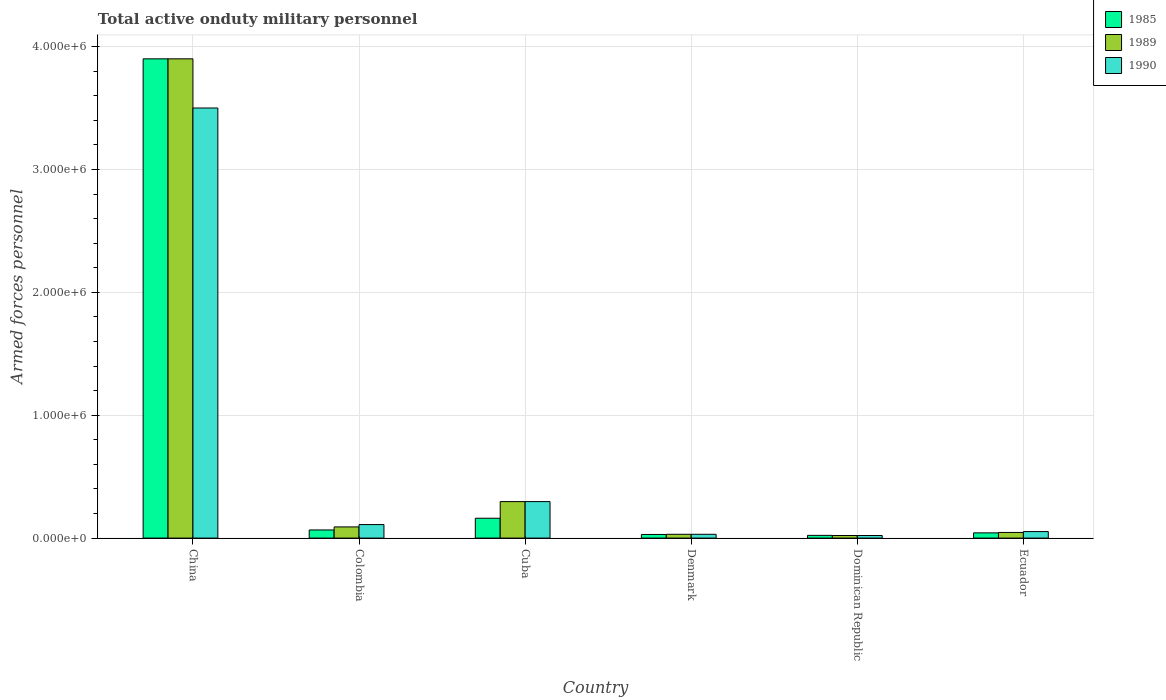How many different coloured bars are there?
Give a very brief answer. 3. How many bars are there on the 5th tick from the left?
Give a very brief answer. 3. How many bars are there on the 2nd tick from the right?
Make the answer very short. 3. What is the label of the 6th group of bars from the left?
Provide a short and direct response. Ecuador. In how many cases, is the number of bars for a given country not equal to the number of legend labels?
Your answer should be compact. 0. What is the number of armed forces personnel in 1985 in China?
Your answer should be very brief. 3.90e+06. Across all countries, what is the maximum number of armed forces personnel in 1985?
Your answer should be compact. 3.90e+06. Across all countries, what is the minimum number of armed forces personnel in 1989?
Your answer should be very brief. 2.10e+04. In which country was the number of armed forces personnel in 1989 minimum?
Make the answer very short. Dominican Republic. What is the total number of armed forces personnel in 1990 in the graph?
Offer a terse response. 4.01e+06. What is the difference between the number of armed forces personnel in 1990 in China and that in Dominican Republic?
Your response must be concise. 3.48e+06. What is the difference between the number of armed forces personnel in 1990 in Colombia and the number of armed forces personnel in 1989 in Ecuador?
Make the answer very short. 6.40e+04. What is the average number of armed forces personnel in 1990 per country?
Keep it short and to the point. 6.69e+05. In how many countries, is the number of armed forces personnel in 1990 greater than 200000?
Provide a succinct answer. 2. What is the ratio of the number of armed forces personnel in 1990 in Colombia to that in Dominican Republic?
Your answer should be very brief. 5.24. Is the number of armed forces personnel in 1989 in Colombia less than that in Cuba?
Offer a very short reply. Yes. What is the difference between the highest and the second highest number of armed forces personnel in 1985?
Ensure brevity in your answer.  3.74e+06. What is the difference between the highest and the lowest number of armed forces personnel in 1985?
Provide a short and direct response. 3.88e+06. In how many countries, is the number of armed forces personnel in 1989 greater than the average number of armed forces personnel in 1989 taken over all countries?
Provide a succinct answer. 1. Is the sum of the number of armed forces personnel in 1990 in Denmark and Ecuador greater than the maximum number of armed forces personnel in 1989 across all countries?
Make the answer very short. No. What does the 1st bar from the left in Ecuador represents?
Give a very brief answer. 1985. What does the 1st bar from the right in Dominican Republic represents?
Offer a very short reply. 1990. Are all the bars in the graph horizontal?
Your response must be concise. No. Does the graph contain any zero values?
Provide a short and direct response. No. What is the title of the graph?
Ensure brevity in your answer.  Total active onduty military personnel. Does "2013" appear as one of the legend labels in the graph?
Your answer should be compact. No. What is the label or title of the X-axis?
Your answer should be compact. Country. What is the label or title of the Y-axis?
Your answer should be compact. Armed forces personnel. What is the Armed forces personnel in 1985 in China?
Provide a short and direct response. 3.90e+06. What is the Armed forces personnel of 1989 in China?
Your response must be concise. 3.90e+06. What is the Armed forces personnel in 1990 in China?
Ensure brevity in your answer.  3.50e+06. What is the Armed forces personnel in 1985 in Colombia?
Give a very brief answer. 6.62e+04. What is the Armed forces personnel of 1989 in Colombia?
Make the answer very short. 9.10e+04. What is the Armed forces personnel of 1990 in Colombia?
Provide a succinct answer. 1.10e+05. What is the Armed forces personnel of 1985 in Cuba?
Your answer should be very brief. 1.62e+05. What is the Armed forces personnel in 1989 in Cuba?
Keep it short and to the point. 2.97e+05. What is the Armed forces personnel in 1990 in Cuba?
Give a very brief answer. 2.97e+05. What is the Armed forces personnel in 1985 in Denmark?
Your answer should be compact. 2.96e+04. What is the Armed forces personnel of 1989 in Denmark?
Your answer should be compact. 3.10e+04. What is the Armed forces personnel in 1990 in Denmark?
Keep it short and to the point. 3.10e+04. What is the Armed forces personnel in 1985 in Dominican Republic?
Provide a succinct answer. 2.22e+04. What is the Armed forces personnel of 1989 in Dominican Republic?
Your response must be concise. 2.10e+04. What is the Armed forces personnel in 1990 in Dominican Republic?
Make the answer very short. 2.10e+04. What is the Armed forces personnel of 1985 in Ecuador?
Your response must be concise. 4.25e+04. What is the Armed forces personnel of 1989 in Ecuador?
Ensure brevity in your answer.  4.60e+04. What is the Armed forces personnel in 1990 in Ecuador?
Offer a terse response. 5.30e+04. Across all countries, what is the maximum Armed forces personnel of 1985?
Provide a short and direct response. 3.90e+06. Across all countries, what is the maximum Armed forces personnel in 1989?
Provide a succinct answer. 3.90e+06. Across all countries, what is the maximum Armed forces personnel of 1990?
Provide a succinct answer. 3.50e+06. Across all countries, what is the minimum Armed forces personnel in 1985?
Your answer should be very brief. 2.22e+04. Across all countries, what is the minimum Armed forces personnel of 1989?
Ensure brevity in your answer.  2.10e+04. Across all countries, what is the minimum Armed forces personnel in 1990?
Offer a very short reply. 2.10e+04. What is the total Armed forces personnel of 1985 in the graph?
Make the answer very short. 4.22e+06. What is the total Armed forces personnel in 1989 in the graph?
Provide a succinct answer. 4.39e+06. What is the total Armed forces personnel of 1990 in the graph?
Provide a short and direct response. 4.01e+06. What is the difference between the Armed forces personnel in 1985 in China and that in Colombia?
Provide a succinct answer. 3.83e+06. What is the difference between the Armed forces personnel of 1989 in China and that in Colombia?
Provide a succinct answer. 3.81e+06. What is the difference between the Armed forces personnel in 1990 in China and that in Colombia?
Keep it short and to the point. 3.39e+06. What is the difference between the Armed forces personnel in 1985 in China and that in Cuba?
Give a very brief answer. 3.74e+06. What is the difference between the Armed forces personnel of 1989 in China and that in Cuba?
Make the answer very short. 3.60e+06. What is the difference between the Armed forces personnel in 1990 in China and that in Cuba?
Provide a short and direct response. 3.20e+06. What is the difference between the Armed forces personnel of 1985 in China and that in Denmark?
Offer a terse response. 3.87e+06. What is the difference between the Armed forces personnel in 1989 in China and that in Denmark?
Offer a terse response. 3.87e+06. What is the difference between the Armed forces personnel in 1990 in China and that in Denmark?
Your answer should be very brief. 3.47e+06. What is the difference between the Armed forces personnel in 1985 in China and that in Dominican Republic?
Your response must be concise. 3.88e+06. What is the difference between the Armed forces personnel of 1989 in China and that in Dominican Republic?
Your answer should be compact. 3.88e+06. What is the difference between the Armed forces personnel in 1990 in China and that in Dominican Republic?
Make the answer very short. 3.48e+06. What is the difference between the Armed forces personnel of 1985 in China and that in Ecuador?
Provide a short and direct response. 3.86e+06. What is the difference between the Armed forces personnel in 1989 in China and that in Ecuador?
Offer a terse response. 3.85e+06. What is the difference between the Armed forces personnel of 1990 in China and that in Ecuador?
Keep it short and to the point. 3.45e+06. What is the difference between the Armed forces personnel in 1985 in Colombia and that in Cuba?
Ensure brevity in your answer.  -9.53e+04. What is the difference between the Armed forces personnel of 1989 in Colombia and that in Cuba?
Keep it short and to the point. -2.06e+05. What is the difference between the Armed forces personnel in 1990 in Colombia and that in Cuba?
Ensure brevity in your answer.  -1.87e+05. What is the difference between the Armed forces personnel of 1985 in Colombia and that in Denmark?
Provide a short and direct response. 3.66e+04. What is the difference between the Armed forces personnel in 1990 in Colombia and that in Denmark?
Provide a short and direct response. 7.90e+04. What is the difference between the Armed forces personnel in 1985 in Colombia and that in Dominican Republic?
Offer a terse response. 4.40e+04. What is the difference between the Armed forces personnel of 1990 in Colombia and that in Dominican Republic?
Provide a short and direct response. 8.90e+04. What is the difference between the Armed forces personnel in 1985 in Colombia and that in Ecuador?
Offer a very short reply. 2.37e+04. What is the difference between the Armed forces personnel in 1989 in Colombia and that in Ecuador?
Give a very brief answer. 4.50e+04. What is the difference between the Armed forces personnel in 1990 in Colombia and that in Ecuador?
Offer a terse response. 5.70e+04. What is the difference between the Armed forces personnel of 1985 in Cuba and that in Denmark?
Provide a short and direct response. 1.32e+05. What is the difference between the Armed forces personnel in 1989 in Cuba and that in Denmark?
Provide a succinct answer. 2.66e+05. What is the difference between the Armed forces personnel in 1990 in Cuba and that in Denmark?
Give a very brief answer. 2.66e+05. What is the difference between the Armed forces personnel in 1985 in Cuba and that in Dominican Republic?
Offer a terse response. 1.39e+05. What is the difference between the Armed forces personnel in 1989 in Cuba and that in Dominican Republic?
Provide a short and direct response. 2.76e+05. What is the difference between the Armed forces personnel of 1990 in Cuba and that in Dominican Republic?
Keep it short and to the point. 2.76e+05. What is the difference between the Armed forces personnel in 1985 in Cuba and that in Ecuador?
Your answer should be compact. 1.19e+05. What is the difference between the Armed forces personnel of 1989 in Cuba and that in Ecuador?
Provide a succinct answer. 2.51e+05. What is the difference between the Armed forces personnel of 1990 in Cuba and that in Ecuador?
Your answer should be very brief. 2.44e+05. What is the difference between the Armed forces personnel of 1985 in Denmark and that in Dominican Republic?
Provide a short and direct response. 7400. What is the difference between the Armed forces personnel of 1989 in Denmark and that in Dominican Republic?
Offer a terse response. 10000. What is the difference between the Armed forces personnel of 1990 in Denmark and that in Dominican Republic?
Your answer should be compact. 10000. What is the difference between the Armed forces personnel of 1985 in Denmark and that in Ecuador?
Provide a short and direct response. -1.29e+04. What is the difference between the Armed forces personnel in 1989 in Denmark and that in Ecuador?
Your answer should be compact. -1.50e+04. What is the difference between the Armed forces personnel of 1990 in Denmark and that in Ecuador?
Provide a short and direct response. -2.20e+04. What is the difference between the Armed forces personnel of 1985 in Dominican Republic and that in Ecuador?
Ensure brevity in your answer.  -2.03e+04. What is the difference between the Armed forces personnel of 1989 in Dominican Republic and that in Ecuador?
Keep it short and to the point. -2.50e+04. What is the difference between the Armed forces personnel of 1990 in Dominican Republic and that in Ecuador?
Provide a short and direct response. -3.20e+04. What is the difference between the Armed forces personnel in 1985 in China and the Armed forces personnel in 1989 in Colombia?
Give a very brief answer. 3.81e+06. What is the difference between the Armed forces personnel of 1985 in China and the Armed forces personnel of 1990 in Colombia?
Your answer should be very brief. 3.79e+06. What is the difference between the Armed forces personnel of 1989 in China and the Armed forces personnel of 1990 in Colombia?
Your answer should be very brief. 3.79e+06. What is the difference between the Armed forces personnel of 1985 in China and the Armed forces personnel of 1989 in Cuba?
Make the answer very short. 3.60e+06. What is the difference between the Armed forces personnel of 1985 in China and the Armed forces personnel of 1990 in Cuba?
Offer a very short reply. 3.60e+06. What is the difference between the Armed forces personnel of 1989 in China and the Armed forces personnel of 1990 in Cuba?
Offer a very short reply. 3.60e+06. What is the difference between the Armed forces personnel in 1985 in China and the Armed forces personnel in 1989 in Denmark?
Offer a very short reply. 3.87e+06. What is the difference between the Armed forces personnel in 1985 in China and the Armed forces personnel in 1990 in Denmark?
Provide a succinct answer. 3.87e+06. What is the difference between the Armed forces personnel of 1989 in China and the Armed forces personnel of 1990 in Denmark?
Provide a short and direct response. 3.87e+06. What is the difference between the Armed forces personnel of 1985 in China and the Armed forces personnel of 1989 in Dominican Republic?
Provide a succinct answer. 3.88e+06. What is the difference between the Armed forces personnel of 1985 in China and the Armed forces personnel of 1990 in Dominican Republic?
Make the answer very short. 3.88e+06. What is the difference between the Armed forces personnel in 1989 in China and the Armed forces personnel in 1990 in Dominican Republic?
Your answer should be very brief. 3.88e+06. What is the difference between the Armed forces personnel of 1985 in China and the Armed forces personnel of 1989 in Ecuador?
Keep it short and to the point. 3.85e+06. What is the difference between the Armed forces personnel in 1985 in China and the Armed forces personnel in 1990 in Ecuador?
Your answer should be very brief. 3.85e+06. What is the difference between the Armed forces personnel of 1989 in China and the Armed forces personnel of 1990 in Ecuador?
Your response must be concise. 3.85e+06. What is the difference between the Armed forces personnel of 1985 in Colombia and the Armed forces personnel of 1989 in Cuba?
Your response must be concise. -2.31e+05. What is the difference between the Armed forces personnel of 1985 in Colombia and the Armed forces personnel of 1990 in Cuba?
Your answer should be compact. -2.31e+05. What is the difference between the Armed forces personnel in 1989 in Colombia and the Armed forces personnel in 1990 in Cuba?
Your response must be concise. -2.06e+05. What is the difference between the Armed forces personnel of 1985 in Colombia and the Armed forces personnel of 1989 in Denmark?
Your response must be concise. 3.52e+04. What is the difference between the Armed forces personnel in 1985 in Colombia and the Armed forces personnel in 1990 in Denmark?
Keep it short and to the point. 3.52e+04. What is the difference between the Armed forces personnel in 1985 in Colombia and the Armed forces personnel in 1989 in Dominican Republic?
Keep it short and to the point. 4.52e+04. What is the difference between the Armed forces personnel in 1985 in Colombia and the Armed forces personnel in 1990 in Dominican Republic?
Your answer should be compact. 4.52e+04. What is the difference between the Armed forces personnel of 1989 in Colombia and the Armed forces personnel of 1990 in Dominican Republic?
Give a very brief answer. 7.00e+04. What is the difference between the Armed forces personnel of 1985 in Colombia and the Armed forces personnel of 1989 in Ecuador?
Offer a terse response. 2.02e+04. What is the difference between the Armed forces personnel in 1985 in Colombia and the Armed forces personnel in 1990 in Ecuador?
Give a very brief answer. 1.32e+04. What is the difference between the Armed forces personnel of 1989 in Colombia and the Armed forces personnel of 1990 in Ecuador?
Keep it short and to the point. 3.80e+04. What is the difference between the Armed forces personnel of 1985 in Cuba and the Armed forces personnel of 1989 in Denmark?
Offer a terse response. 1.30e+05. What is the difference between the Armed forces personnel of 1985 in Cuba and the Armed forces personnel of 1990 in Denmark?
Provide a short and direct response. 1.30e+05. What is the difference between the Armed forces personnel of 1989 in Cuba and the Armed forces personnel of 1990 in Denmark?
Keep it short and to the point. 2.66e+05. What is the difference between the Armed forces personnel of 1985 in Cuba and the Armed forces personnel of 1989 in Dominican Republic?
Ensure brevity in your answer.  1.40e+05. What is the difference between the Armed forces personnel of 1985 in Cuba and the Armed forces personnel of 1990 in Dominican Republic?
Ensure brevity in your answer.  1.40e+05. What is the difference between the Armed forces personnel in 1989 in Cuba and the Armed forces personnel in 1990 in Dominican Republic?
Offer a very short reply. 2.76e+05. What is the difference between the Armed forces personnel in 1985 in Cuba and the Armed forces personnel in 1989 in Ecuador?
Provide a succinct answer. 1.16e+05. What is the difference between the Armed forces personnel in 1985 in Cuba and the Armed forces personnel in 1990 in Ecuador?
Offer a terse response. 1.08e+05. What is the difference between the Armed forces personnel in 1989 in Cuba and the Armed forces personnel in 1990 in Ecuador?
Offer a very short reply. 2.44e+05. What is the difference between the Armed forces personnel of 1985 in Denmark and the Armed forces personnel of 1989 in Dominican Republic?
Your answer should be compact. 8600. What is the difference between the Armed forces personnel of 1985 in Denmark and the Armed forces personnel of 1990 in Dominican Republic?
Your response must be concise. 8600. What is the difference between the Armed forces personnel in 1985 in Denmark and the Armed forces personnel in 1989 in Ecuador?
Your response must be concise. -1.64e+04. What is the difference between the Armed forces personnel in 1985 in Denmark and the Armed forces personnel in 1990 in Ecuador?
Your answer should be very brief. -2.34e+04. What is the difference between the Armed forces personnel in 1989 in Denmark and the Armed forces personnel in 1990 in Ecuador?
Offer a very short reply. -2.20e+04. What is the difference between the Armed forces personnel in 1985 in Dominican Republic and the Armed forces personnel in 1989 in Ecuador?
Give a very brief answer. -2.38e+04. What is the difference between the Armed forces personnel in 1985 in Dominican Republic and the Armed forces personnel in 1990 in Ecuador?
Your answer should be very brief. -3.08e+04. What is the difference between the Armed forces personnel of 1989 in Dominican Republic and the Armed forces personnel of 1990 in Ecuador?
Provide a succinct answer. -3.20e+04. What is the average Armed forces personnel of 1985 per country?
Offer a terse response. 7.04e+05. What is the average Armed forces personnel of 1989 per country?
Make the answer very short. 7.31e+05. What is the average Armed forces personnel of 1990 per country?
Offer a very short reply. 6.69e+05. What is the difference between the Armed forces personnel of 1985 and Armed forces personnel of 1990 in China?
Ensure brevity in your answer.  4.00e+05. What is the difference between the Armed forces personnel in 1989 and Armed forces personnel in 1990 in China?
Ensure brevity in your answer.  4.00e+05. What is the difference between the Armed forces personnel in 1985 and Armed forces personnel in 1989 in Colombia?
Provide a succinct answer. -2.48e+04. What is the difference between the Armed forces personnel of 1985 and Armed forces personnel of 1990 in Colombia?
Your response must be concise. -4.38e+04. What is the difference between the Armed forces personnel in 1989 and Armed forces personnel in 1990 in Colombia?
Offer a terse response. -1.90e+04. What is the difference between the Armed forces personnel of 1985 and Armed forces personnel of 1989 in Cuba?
Provide a short and direct response. -1.36e+05. What is the difference between the Armed forces personnel in 1985 and Armed forces personnel in 1990 in Cuba?
Provide a succinct answer. -1.36e+05. What is the difference between the Armed forces personnel in 1989 and Armed forces personnel in 1990 in Cuba?
Ensure brevity in your answer.  0. What is the difference between the Armed forces personnel of 1985 and Armed forces personnel of 1989 in Denmark?
Ensure brevity in your answer.  -1400. What is the difference between the Armed forces personnel of 1985 and Armed forces personnel of 1990 in Denmark?
Provide a short and direct response. -1400. What is the difference between the Armed forces personnel in 1985 and Armed forces personnel in 1989 in Dominican Republic?
Offer a very short reply. 1200. What is the difference between the Armed forces personnel in 1985 and Armed forces personnel in 1990 in Dominican Republic?
Offer a terse response. 1200. What is the difference between the Armed forces personnel in 1989 and Armed forces personnel in 1990 in Dominican Republic?
Offer a very short reply. 0. What is the difference between the Armed forces personnel in 1985 and Armed forces personnel in 1989 in Ecuador?
Your response must be concise. -3500. What is the difference between the Armed forces personnel of 1985 and Armed forces personnel of 1990 in Ecuador?
Provide a short and direct response. -1.05e+04. What is the difference between the Armed forces personnel in 1989 and Armed forces personnel in 1990 in Ecuador?
Your answer should be very brief. -7000. What is the ratio of the Armed forces personnel in 1985 in China to that in Colombia?
Your response must be concise. 58.91. What is the ratio of the Armed forces personnel of 1989 in China to that in Colombia?
Keep it short and to the point. 42.86. What is the ratio of the Armed forces personnel of 1990 in China to that in Colombia?
Offer a terse response. 31.82. What is the ratio of the Armed forces personnel in 1985 in China to that in Cuba?
Provide a succinct answer. 24.15. What is the ratio of the Armed forces personnel of 1989 in China to that in Cuba?
Your answer should be very brief. 13.13. What is the ratio of the Armed forces personnel in 1990 in China to that in Cuba?
Offer a terse response. 11.78. What is the ratio of the Armed forces personnel in 1985 in China to that in Denmark?
Provide a short and direct response. 131.76. What is the ratio of the Armed forces personnel in 1989 in China to that in Denmark?
Make the answer very short. 125.81. What is the ratio of the Armed forces personnel in 1990 in China to that in Denmark?
Offer a terse response. 112.9. What is the ratio of the Armed forces personnel of 1985 in China to that in Dominican Republic?
Your response must be concise. 175.68. What is the ratio of the Armed forces personnel in 1989 in China to that in Dominican Republic?
Offer a very short reply. 185.71. What is the ratio of the Armed forces personnel of 1990 in China to that in Dominican Republic?
Provide a short and direct response. 166.67. What is the ratio of the Armed forces personnel of 1985 in China to that in Ecuador?
Your response must be concise. 91.76. What is the ratio of the Armed forces personnel in 1989 in China to that in Ecuador?
Ensure brevity in your answer.  84.78. What is the ratio of the Armed forces personnel of 1990 in China to that in Ecuador?
Provide a short and direct response. 66.04. What is the ratio of the Armed forces personnel in 1985 in Colombia to that in Cuba?
Keep it short and to the point. 0.41. What is the ratio of the Armed forces personnel in 1989 in Colombia to that in Cuba?
Your answer should be very brief. 0.31. What is the ratio of the Armed forces personnel of 1990 in Colombia to that in Cuba?
Keep it short and to the point. 0.37. What is the ratio of the Armed forces personnel in 1985 in Colombia to that in Denmark?
Your answer should be compact. 2.24. What is the ratio of the Armed forces personnel of 1989 in Colombia to that in Denmark?
Your answer should be compact. 2.94. What is the ratio of the Armed forces personnel in 1990 in Colombia to that in Denmark?
Your response must be concise. 3.55. What is the ratio of the Armed forces personnel of 1985 in Colombia to that in Dominican Republic?
Your answer should be compact. 2.98. What is the ratio of the Armed forces personnel of 1989 in Colombia to that in Dominican Republic?
Provide a short and direct response. 4.33. What is the ratio of the Armed forces personnel in 1990 in Colombia to that in Dominican Republic?
Give a very brief answer. 5.24. What is the ratio of the Armed forces personnel in 1985 in Colombia to that in Ecuador?
Keep it short and to the point. 1.56. What is the ratio of the Armed forces personnel of 1989 in Colombia to that in Ecuador?
Provide a succinct answer. 1.98. What is the ratio of the Armed forces personnel in 1990 in Colombia to that in Ecuador?
Offer a terse response. 2.08. What is the ratio of the Armed forces personnel in 1985 in Cuba to that in Denmark?
Your response must be concise. 5.46. What is the ratio of the Armed forces personnel in 1989 in Cuba to that in Denmark?
Offer a terse response. 9.58. What is the ratio of the Armed forces personnel of 1990 in Cuba to that in Denmark?
Offer a very short reply. 9.58. What is the ratio of the Armed forces personnel in 1985 in Cuba to that in Dominican Republic?
Your response must be concise. 7.27. What is the ratio of the Armed forces personnel of 1989 in Cuba to that in Dominican Republic?
Provide a short and direct response. 14.14. What is the ratio of the Armed forces personnel in 1990 in Cuba to that in Dominican Republic?
Your response must be concise. 14.14. What is the ratio of the Armed forces personnel in 1989 in Cuba to that in Ecuador?
Make the answer very short. 6.46. What is the ratio of the Armed forces personnel of 1990 in Cuba to that in Ecuador?
Make the answer very short. 5.6. What is the ratio of the Armed forces personnel of 1989 in Denmark to that in Dominican Republic?
Offer a terse response. 1.48. What is the ratio of the Armed forces personnel in 1990 in Denmark to that in Dominican Republic?
Provide a short and direct response. 1.48. What is the ratio of the Armed forces personnel of 1985 in Denmark to that in Ecuador?
Offer a very short reply. 0.7. What is the ratio of the Armed forces personnel in 1989 in Denmark to that in Ecuador?
Offer a terse response. 0.67. What is the ratio of the Armed forces personnel of 1990 in Denmark to that in Ecuador?
Offer a terse response. 0.58. What is the ratio of the Armed forces personnel of 1985 in Dominican Republic to that in Ecuador?
Ensure brevity in your answer.  0.52. What is the ratio of the Armed forces personnel of 1989 in Dominican Republic to that in Ecuador?
Provide a succinct answer. 0.46. What is the ratio of the Armed forces personnel of 1990 in Dominican Republic to that in Ecuador?
Ensure brevity in your answer.  0.4. What is the difference between the highest and the second highest Armed forces personnel in 1985?
Ensure brevity in your answer.  3.74e+06. What is the difference between the highest and the second highest Armed forces personnel in 1989?
Offer a terse response. 3.60e+06. What is the difference between the highest and the second highest Armed forces personnel in 1990?
Your answer should be compact. 3.20e+06. What is the difference between the highest and the lowest Armed forces personnel of 1985?
Keep it short and to the point. 3.88e+06. What is the difference between the highest and the lowest Armed forces personnel of 1989?
Give a very brief answer. 3.88e+06. What is the difference between the highest and the lowest Armed forces personnel in 1990?
Keep it short and to the point. 3.48e+06. 